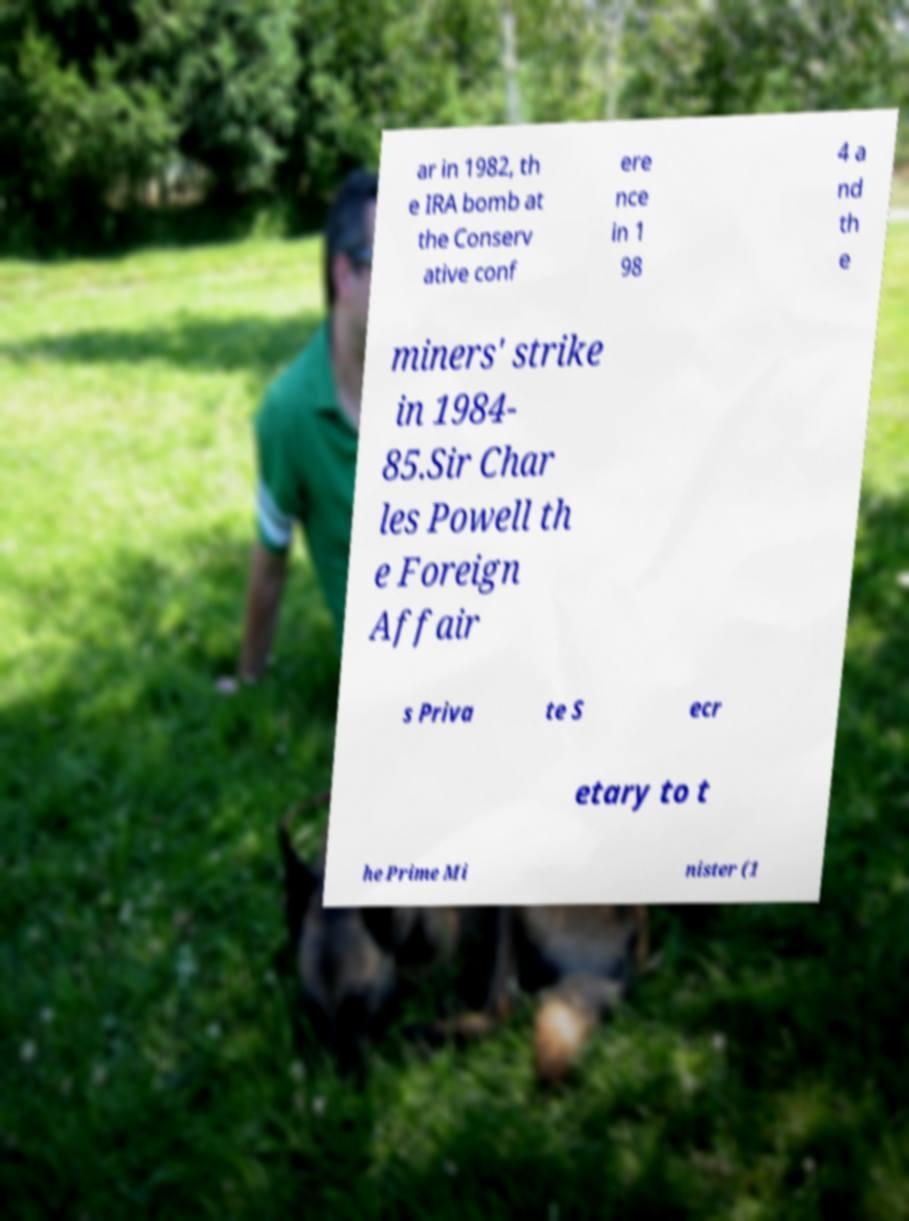Could you extract and type out the text from this image? ar in 1982, th e IRA bomb at the Conserv ative conf ere nce in 1 98 4 a nd th e miners' strike in 1984- 85.Sir Char les Powell th e Foreign Affair s Priva te S ecr etary to t he Prime Mi nister (1 